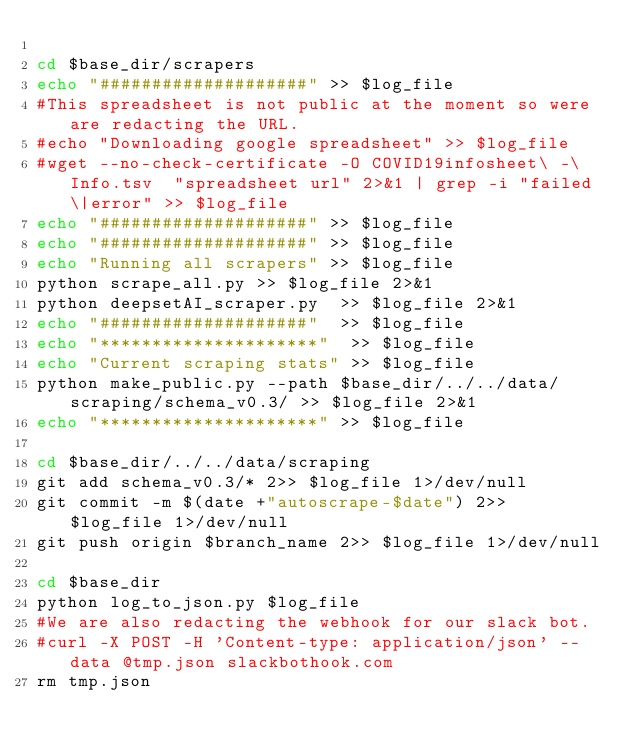<code> <loc_0><loc_0><loc_500><loc_500><_Bash_>
cd $base_dir/scrapers
echo "####################" >> $log_file
#This spreadsheet is not public at the moment so were are redacting the URL.
#echo "Downloading google spreadsheet" >> $log_file
#wget --no-check-certificate -O COVID19infosheet\ -\ Info.tsv  "spreadsheet url" 2>&1 | grep -i "failed\|error" >> $log_file
echo "####################" >> $log_file
echo "####################" >> $log_file
echo "Running all scrapers" >> $log_file
python scrape_all.py >> $log_file 2>&1
python deepsetAI_scraper.py  >> $log_file 2>&1
echo "####################"  >> $log_file
echo "*********************"  >> $log_file
echo "Current scraping stats" >> $log_file
python make_public.py --path $base_dir/../../data/scraping/schema_v0.3/ >> $log_file 2>&1
echo "*********************" >> $log_file

cd $base_dir/../../data/scraping
git add schema_v0.3/* 2>> $log_file 1>/dev/null
git commit -m $(date +"autoscrape-$date") 2>> $log_file 1>/dev/null
git push origin $branch_name 2>> $log_file 1>/dev/null

cd $base_dir
python log_to_json.py $log_file
#We are also redacting the webhook for our slack bot. 
#curl -X POST -H 'Content-type: application/json' --data @tmp.json slackbothook.com
rm tmp.json
</code> 